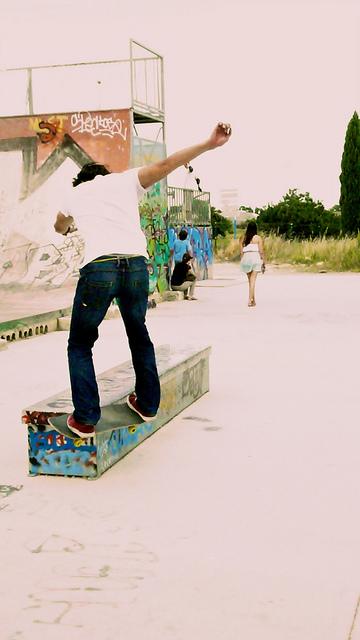Yes she is?
Quick response, please. Skateboarding. What is the man jumping with?
Quick response, please. Skateboard. Is the girl walking away?
Concise answer only. Yes. 